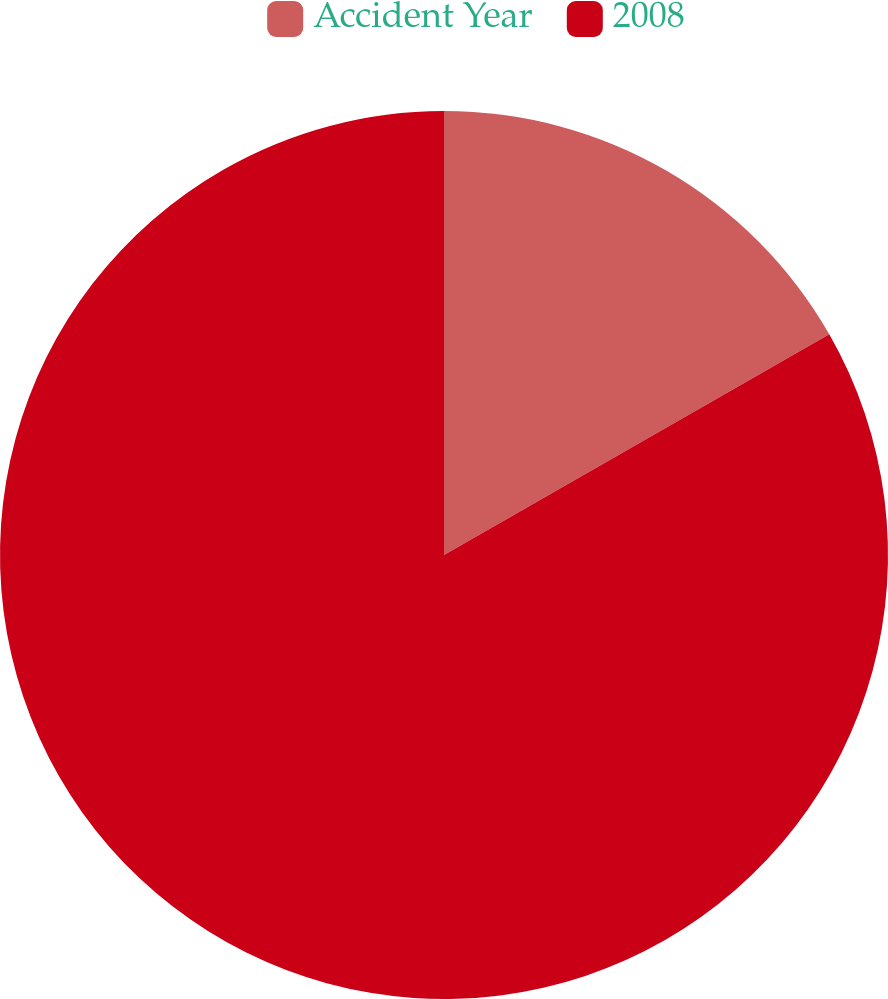Convert chart to OTSL. <chart><loc_0><loc_0><loc_500><loc_500><pie_chart><fcel>Accident Year<fcel>2008<nl><fcel>16.72%<fcel>83.28%<nl></chart> 